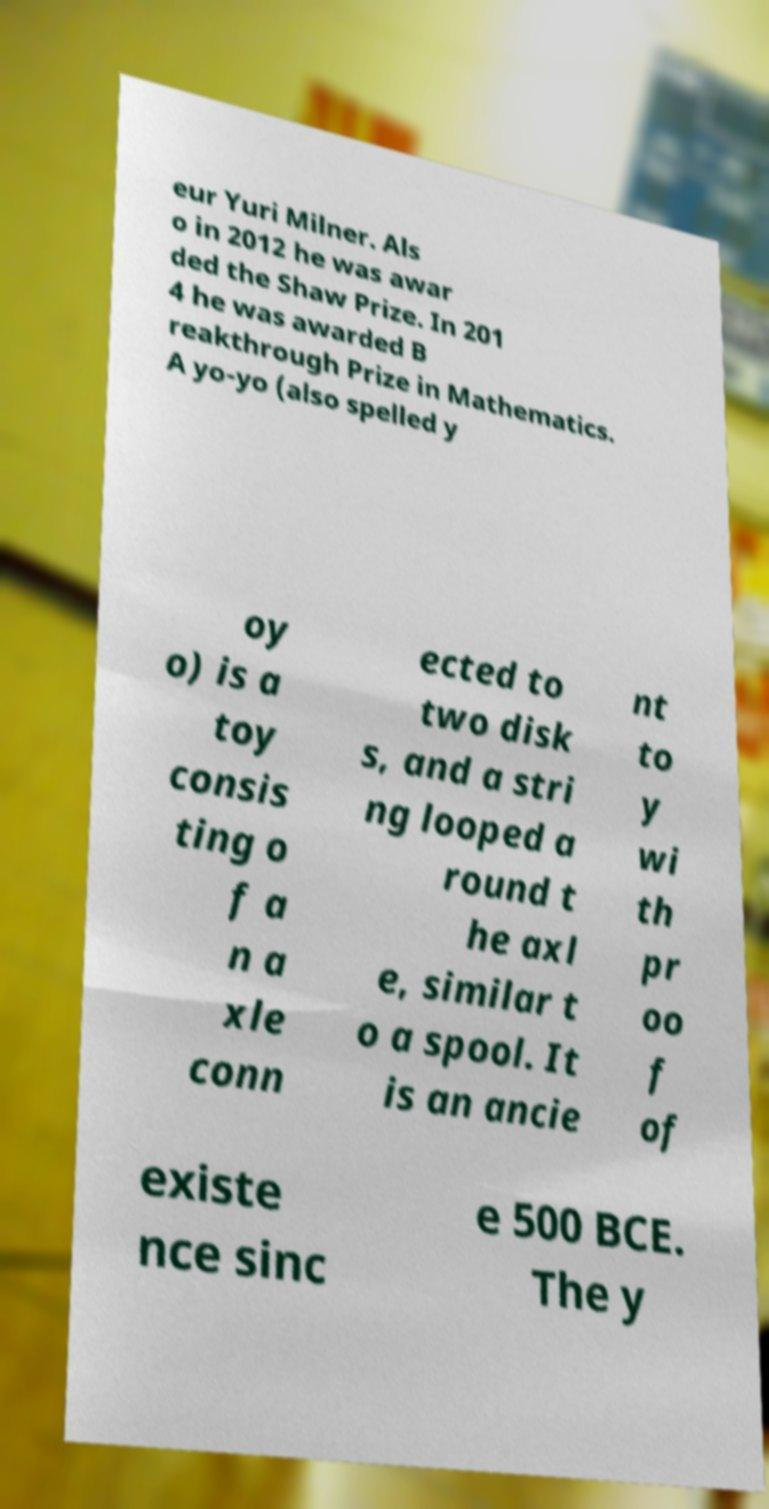Could you assist in decoding the text presented in this image and type it out clearly? eur Yuri Milner. Als o in 2012 he was awar ded the Shaw Prize. In 201 4 he was awarded B reakthrough Prize in Mathematics. A yo-yo (also spelled y oy o) is a toy consis ting o f a n a xle conn ected to two disk s, and a stri ng looped a round t he axl e, similar t o a spool. It is an ancie nt to y wi th pr oo f of existe nce sinc e 500 BCE. The y 